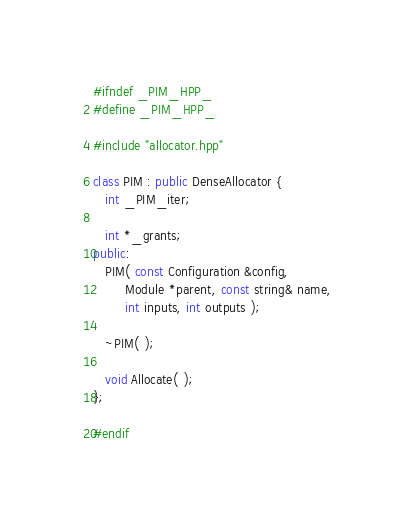<code> <loc_0><loc_0><loc_500><loc_500><_C++_>#ifndef _PIM_HPP_
#define _PIM_HPP_

#include "allocator.hpp"

class PIM : public DenseAllocator {
   int _PIM_iter;

   int *_grants;
public:
   PIM( const Configuration &config,
        Module *parent, const string& name,
        int inputs, int outputs );

   ~PIM( );

   void Allocate( );
};

#endif
</code> 